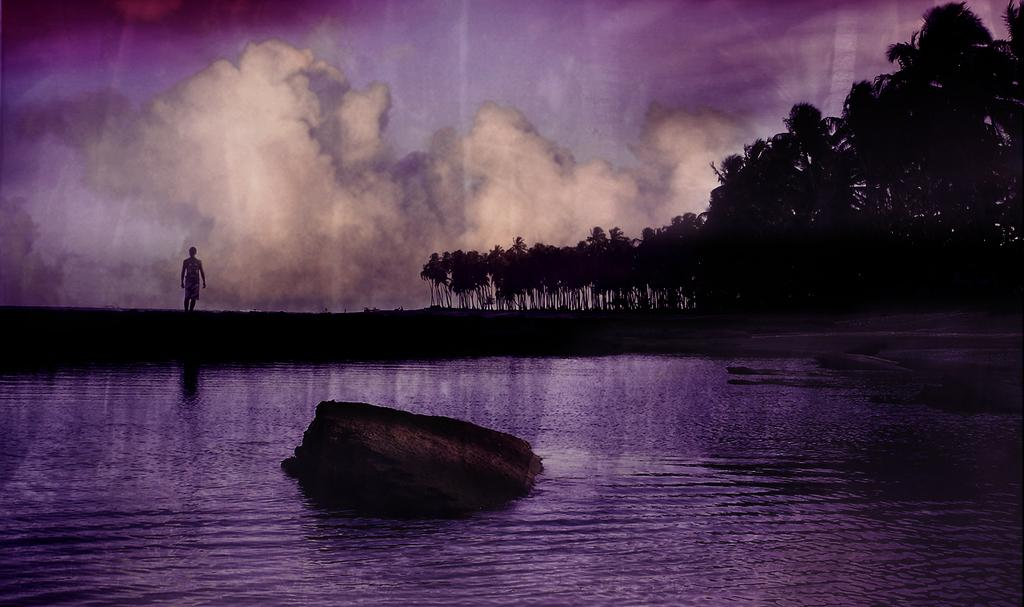What is one of the natural elements present in the image? There is water in the image. What type of terrain can be seen in the image? There is a rock and grass in the image. Is there any human presence in the image? Yes, there is a person standing in the image. What other natural elements are present in the image? There are trees in the image. What part of the natural environment is visible in the image? The sky is visible in the image. Can you tell if the image has been altered in any way? Yes, the image appears to be edited. How does the person in the image distribute their self-awareness? There is no indication in the image of the person's self-awareness or how it might be distributed. 